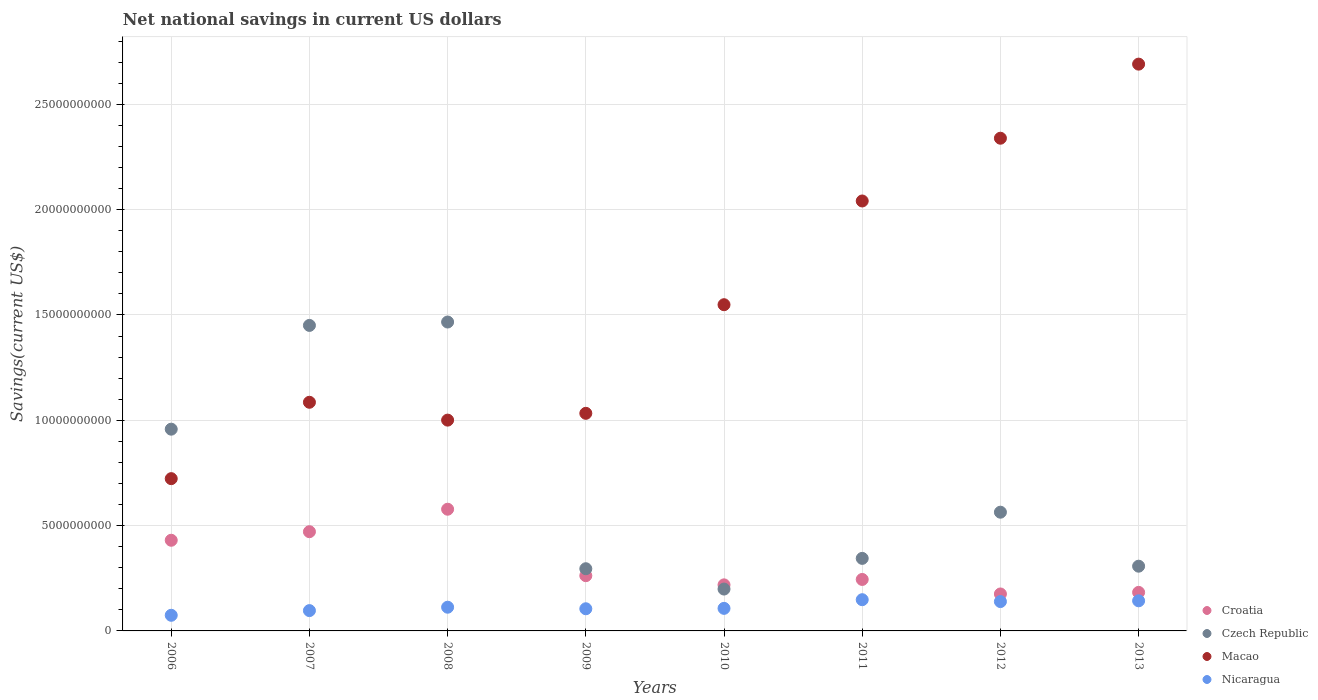What is the net national savings in Croatia in 2008?
Provide a short and direct response. 5.78e+09. Across all years, what is the maximum net national savings in Nicaragua?
Provide a short and direct response. 1.48e+09. Across all years, what is the minimum net national savings in Croatia?
Provide a succinct answer. 1.75e+09. What is the total net national savings in Croatia in the graph?
Keep it short and to the point. 2.56e+1. What is the difference between the net national savings in Macao in 2011 and that in 2013?
Ensure brevity in your answer.  -6.50e+09. What is the difference between the net national savings in Czech Republic in 2009 and the net national savings in Croatia in 2007?
Provide a succinct answer. -1.76e+09. What is the average net national savings in Macao per year?
Keep it short and to the point. 1.56e+1. In the year 2012, what is the difference between the net national savings in Nicaragua and net national savings in Croatia?
Your response must be concise. -3.61e+08. What is the ratio of the net national savings in Czech Republic in 2010 to that in 2013?
Offer a terse response. 0.65. What is the difference between the highest and the second highest net national savings in Nicaragua?
Your answer should be compact. 5.26e+07. What is the difference between the highest and the lowest net national savings in Nicaragua?
Offer a very short reply. 7.40e+08. In how many years, is the net national savings in Nicaragua greater than the average net national savings in Nicaragua taken over all years?
Give a very brief answer. 3. Is the sum of the net national savings in Macao in 2007 and 2011 greater than the maximum net national savings in Czech Republic across all years?
Ensure brevity in your answer.  Yes. Is it the case that in every year, the sum of the net national savings in Macao and net national savings in Croatia  is greater than the sum of net national savings in Nicaragua and net national savings in Czech Republic?
Keep it short and to the point. Yes. Does the net national savings in Macao monotonically increase over the years?
Your answer should be very brief. No. Is the net national savings in Czech Republic strictly less than the net national savings in Croatia over the years?
Provide a succinct answer. No. How many dotlines are there?
Keep it short and to the point. 4. How many years are there in the graph?
Your response must be concise. 8. Where does the legend appear in the graph?
Your response must be concise. Bottom right. How many legend labels are there?
Provide a succinct answer. 4. How are the legend labels stacked?
Give a very brief answer. Vertical. What is the title of the graph?
Keep it short and to the point. Net national savings in current US dollars. What is the label or title of the X-axis?
Make the answer very short. Years. What is the label or title of the Y-axis?
Keep it short and to the point. Savings(current US$). What is the Savings(current US$) of Croatia in 2006?
Your answer should be compact. 4.30e+09. What is the Savings(current US$) in Czech Republic in 2006?
Your response must be concise. 9.58e+09. What is the Savings(current US$) of Macao in 2006?
Provide a succinct answer. 7.23e+09. What is the Savings(current US$) in Nicaragua in 2006?
Ensure brevity in your answer.  7.42e+08. What is the Savings(current US$) in Croatia in 2007?
Give a very brief answer. 4.71e+09. What is the Savings(current US$) of Czech Republic in 2007?
Offer a terse response. 1.45e+1. What is the Savings(current US$) of Macao in 2007?
Keep it short and to the point. 1.09e+1. What is the Savings(current US$) in Nicaragua in 2007?
Your response must be concise. 9.64e+08. What is the Savings(current US$) of Croatia in 2008?
Your response must be concise. 5.78e+09. What is the Savings(current US$) of Czech Republic in 2008?
Make the answer very short. 1.47e+1. What is the Savings(current US$) in Macao in 2008?
Your response must be concise. 1.00e+1. What is the Savings(current US$) in Nicaragua in 2008?
Your answer should be very brief. 1.13e+09. What is the Savings(current US$) of Croatia in 2009?
Ensure brevity in your answer.  2.62e+09. What is the Savings(current US$) of Czech Republic in 2009?
Offer a terse response. 2.95e+09. What is the Savings(current US$) in Macao in 2009?
Your response must be concise. 1.03e+1. What is the Savings(current US$) in Nicaragua in 2009?
Your answer should be very brief. 1.05e+09. What is the Savings(current US$) in Croatia in 2010?
Provide a succinct answer. 2.19e+09. What is the Savings(current US$) in Czech Republic in 2010?
Your answer should be very brief. 1.99e+09. What is the Savings(current US$) of Macao in 2010?
Ensure brevity in your answer.  1.55e+1. What is the Savings(current US$) of Nicaragua in 2010?
Provide a succinct answer. 1.07e+09. What is the Savings(current US$) in Croatia in 2011?
Provide a short and direct response. 2.44e+09. What is the Savings(current US$) of Czech Republic in 2011?
Your response must be concise. 3.44e+09. What is the Savings(current US$) of Macao in 2011?
Provide a succinct answer. 2.04e+1. What is the Savings(current US$) in Nicaragua in 2011?
Give a very brief answer. 1.48e+09. What is the Savings(current US$) in Croatia in 2012?
Give a very brief answer. 1.75e+09. What is the Savings(current US$) in Czech Republic in 2012?
Offer a very short reply. 5.64e+09. What is the Savings(current US$) in Macao in 2012?
Provide a succinct answer. 2.34e+1. What is the Savings(current US$) in Nicaragua in 2012?
Your response must be concise. 1.39e+09. What is the Savings(current US$) in Croatia in 2013?
Provide a succinct answer. 1.83e+09. What is the Savings(current US$) in Czech Republic in 2013?
Your response must be concise. 3.07e+09. What is the Savings(current US$) in Macao in 2013?
Keep it short and to the point. 2.69e+1. What is the Savings(current US$) of Nicaragua in 2013?
Your answer should be very brief. 1.43e+09. Across all years, what is the maximum Savings(current US$) of Croatia?
Ensure brevity in your answer.  5.78e+09. Across all years, what is the maximum Savings(current US$) of Czech Republic?
Ensure brevity in your answer.  1.47e+1. Across all years, what is the maximum Savings(current US$) in Macao?
Ensure brevity in your answer.  2.69e+1. Across all years, what is the maximum Savings(current US$) in Nicaragua?
Ensure brevity in your answer.  1.48e+09. Across all years, what is the minimum Savings(current US$) in Croatia?
Your response must be concise. 1.75e+09. Across all years, what is the minimum Savings(current US$) in Czech Republic?
Make the answer very short. 1.99e+09. Across all years, what is the minimum Savings(current US$) of Macao?
Give a very brief answer. 7.23e+09. Across all years, what is the minimum Savings(current US$) in Nicaragua?
Your answer should be very brief. 7.42e+08. What is the total Savings(current US$) in Croatia in the graph?
Ensure brevity in your answer.  2.56e+1. What is the total Savings(current US$) of Czech Republic in the graph?
Your response must be concise. 5.58e+1. What is the total Savings(current US$) in Macao in the graph?
Your response must be concise. 1.25e+11. What is the total Savings(current US$) in Nicaragua in the graph?
Provide a short and direct response. 9.26e+09. What is the difference between the Savings(current US$) in Croatia in 2006 and that in 2007?
Ensure brevity in your answer.  -4.07e+08. What is the difference between the Savings(current US$) of Czech Republic in 2006 and that in 2007?
Your answer should be very brief. -4.93e+09. What is the difference between the Savings(current US$) of Macao in 2006 and that in 2007?
Give a very brief answer. -3.63e+09. What is the difference between the Savings(current US$) in Nicaragua in 2006 and that in 2007?
Provide a succinct answer. -2.22e+08. What is the difference between the Savings(current US$) in Croatia in 2006 and that in 2008?
Give a very brief answer. -1.47e+09. What is the difference between the Savings(current US$) in Czech Republic in 2006 and that in 2008?
Your answer should be very brief. -5.09e+09. What is the difference between the Savings(current US$) in Macao in 2006 and that in 2008?
Offer a terse response. -2.78e+09. What is the difference between the Savings(current US$) in Nicaragua in 2006 and that in 2008?
Your answer should be very brief. -3.83e+08. What is the difference between the Savings(current US$) in Croatia in 2006 and that in 2009?
Provide a succinct answer. 1.68e+09. What is the difference between the Savings(current US$) of Czech Republic in 2006 and that in 2009?
Offer a very short reply. 6.63e+09. What is the difference between the Savings(current US$) in Macao in 2006 and that in 2009?
Your response must be concise. -3.10e+09. What is the difference between the Savings(current US$) of Nicaragua in 2006 and that in 2009?
Ensure brevity in your answer.  -3.10e+08. What is the difference between the Savings(current US$) of Croatia in 2006 and that in 2010?
Your answer should be very brief. 2.12e+09. What is the difference between the Savings(current US$) of Czech Republic in 2006 and that in 2010?
Ensure brevity in your answer.  7.59e+09. What is the difference between the Savings(current US$) in Macao in 2006 and that in 2010?
Keep it short and to the point. -8.26e+09. What is the difference between the Savings(current US$) in Nicaragua in 2006 and that in 2010?
Your answer should be very brief. -3.29e+08. What is the difference between the Savings(current US$) in Croatia in 2006 and that in 2011?
Your response must be concise. 1.86e+09. What is the difference between the Savings(current US$) of Czech Republic in 2006 and that in 2011?
Give a very brief answer. 6.13e+09. What is the difference between the Savings(current US$) in Macao in 2006 and that in 2011?
Provide a succinct answer. -1.32e+1. What is the difference between the Savings(current US$) in Nicaragua in 2006 and that in 2011?
Keep it short and to the point. -7.40e+08. What is the difference between the Savings(current US$) in Croatia in 2006 and that in 2012?
Provide a short and direct response. 2.55e+09. What is the difference between the Savings(current US$) in Czech Republic in 2006 and that in 2012?
Make the answer very short. 3.94e+09. What is the difference between the Savings(current US$) in Macao in 2006 and that in 2012?
Your answer should be very brief. -1.62e+1. What is the difference between the Savings(current US$) in Nicaragua in 2006 and that in 2012?
Keep it short and to the point. -6.51e+08. What is the difference between the Savings(current US$) of Croatia in 2006 and that in 2013?
Ensure brevity in your answer.  2.47e+09. What is the difference between the Savings(current US$) in Czech Republic in 2006 and that in 2013?
Your answer should be compact. 6.50e+09. What is the difference between the Savings(current US$) of Macao in 2006 and that in 2013?
Offer a terse response. -1.97e+1. What is the difference between the Savings(current US$) in Nicaragua in 2006 and that in 2013?
Provide a short and direct response. -6.87e+08. What is the difference between the Savings(current US$) in Croatia in 2007 and that in 2008?
Your answer should be very brief. -1.07e+09. What is the difference between the Savings(current US$) in Czech Republic in 2007 and that in 2008?
Your answer should be compact. -1.61e+08. What is the difference between the Savings(current US$) of Macao in 2007 and that in 2008?
Ensure brevity in your answer.  8.47e+08. What is the difference between the Savings(current US$) in Nicaragua in 2007 and that in 2008?
Keep it short and to the point. -1.61e+08. What is the difference between the Savings(current US$) of Croatia in 2007 and that in 2009?
Make the answer very short. 2.09e+09. What is the difference between the Savings(current US$) of Czech Republic in 2007 and that in 2009?
Make the answer very short. 1.16e+1. What is the difference between the Savings(current US$) of Macao in 2007 and that in 2009?
Provide a short and direct response. 5.25e+08. What is the difference between the Savings(current US$) in Nicaragua in 2007 and that in 2009?
Provide a succinct answer. -8.77e+07. What is the difference between the Savings(current US$) in Croatia in 2007 and that in 2010?
Provide a short and direct response. 2.52e+09. What is the difference between the Savings(current US$) of Czech Republic in 2007 and that in 2010?
Your response must be concise. 1.25e+1. What is the difference between the Savings(current US$) of Macao in 2007 and that in 2010?
Offer a very short reply. -4.63e+09. What is the difference between the Savings(current US$) in Nicaragua in 2007 and that in 2010?
Your answer should be compact. -1.07e+08. What is the difference between the Savings(current US$) of Croatia in 2007 and that in 2011?
Make the answer very short. 2.27e+09. What is the difference between the Savings(current US$) of Czech Republic in 2007 and that in 2011?
Make the answer very short. 1.11e+1. What is the difference between the Savings(current US$) in Macao in 2007 and that in 2011?
Your answer should be very brief. -9.56e+09. What is the difference between the Savings(current US$) of Nicaragua in 2007 and that in 2011?
Your answer should be compact. -5.18e+08. What is the difference between the Savings(current US$) in Croatia in 2007 and that in 2012?
Offer a terse response. 2.96e+09. What is the difference between the Savings(current US$) in Czech Republic in 2007 and that in 2012?
Give a very brief answer. 8.87e+09. What is the difference between the Savings(current US$) of Macao in 2007 and that in 2012?
Your response must be concise. -1.25e+1. What is the difference between the Savings(current US$) in Nicaragua in 2007 and that in 2012?
Offer a very short reply. -4.29e+08. What is the difference between the Savings(current US$) of Croatia in 2007 and that in 2013?
Ensure brevity in your answer.  2.88e+09. What is the difference between the Savings(current US$) of Czech Republic in 2007 and that in 2013?
Your answer should be very brief. 1.14e+1. What is the difference between the Savings(current US$) in Macao in 2007 and that in 2013?
Ensure brevity in your answer.  -1.61e+1. What is the difference between the Savings(current US$) of Nicaragua in 2007 and that in 2013?
Your answer should be very brief. -4.65e+08. What is the difference between the Savings(current US$) of Croatia in 2008 and that in 2009?
Ensure brevity in your answer.  3.16e+09. What is the difference between the Savings(current US$) in Czech Republic in 2008 and that in 2009?
Your response must be concise. 1.17e+1. What is the difference between the Savings(current US$) of Macao in 2008 and that in 2009?
Make the answer very short. -3.23e+08. What is the difference between the Savings(current US$) of Nicaragua in 2008 and that in 2009?
Ensure brevity in your answer.  7.33e+07. What is the difference between the Savings(current US$) of Croatia in 2008 and that in 2010?
Make the answer very short. 3.59e+09. What is the difference between the Savings(current US$) in Czech Republic in 2008 and that in 2010?
Offer a very short reply. 1.27e+1. What is the difference between the Savings(current US$) of Macao in 2008 and that in 2010?
Your response must be concise. -5.48e+09. What is the difference between the Savings(current US$) of Nicaragua in 2008 and that in 2010?
Keep it short and to the point. 5.43e+07. What is the difference between the Savings(current US$) in Croatia in 2008 and that in 2011?
Give a very brief answer. 3.33e+09. What is the difference between the Savings(current US$) of Czech Republic in 2008 and that in 2011?
Your answer should be compact. 1.12e+1. What is the difference between the Savings(current US$) in Macao in 2008 and that in 2011?
Provide a short and direct response. -1.04e+1. What is the difference between the Savings(current US$) in Nicaragua in 2008 and that in 2011?
Your answer should be very brief. -3.57e+08. What is the difference between the Savings(current US$) of Croatia in 2008 and that in 2012?
Your answer should be very brief. 4.02e+09. What is the difference between the Savings(current US$) of Czech Republic in 2008 and that in 2012?
Your answer should be compact. 9.03e+09. What is the difference between the Savings(current US$) of Macao in 2008 and that in 2012?
Provide a short and direct response. -1.34e+1. What is the difference between the Savings(current US$) of Nicaragua in 2008 and that in 2012?
Provide a short and direct response. -2.68e+08. What is the difference between the Savings(current US$) of Croatia in 2008 and that in 2013?
Your answer should be compact. 3.95e+09. What is the difference between the Savings(current US$) in Czech Republic in 2008 and that in 2013?
Provide a short and direct response. 1.16e+1. What is the difference between the Savings(current US$) in Macao in 2008 and that in 2013?
Provide a short and direct response. -1.69e+1. What is the difference between the Savings(current US$) of Nicaragua in 2008 and that in 2013?
Provide a short and direct response. -3.04e+08. What is the difference between the Savings(current US$) in Croatia in 2009 and that in 2010?
Your response must be concise. 4.35e+08. What is the difference between the Savings(current US$) of Czech Republic in 2009 and that in 2010?
Your answer should be very brief. 9.65e+08. What is the difference between the Savings(current US$) of Macao in 2009 and that in 2010?
Keep it short and to the point. -5.16e+09. What is the difference between the Savings(current US$) in Nicaragua in 2009 and that in 2010?
Ensure brevity in your answer.  -1.91e+07. What is the difference between the Savings(current US$) of Croatia in 2009 and that in 2011?
Your response must be concise. 1.79e+08. What is the difference between the Savings(current US$) in Czech Republic in 2009 and that in 2011?
Keep it short and to the point. -4.91e+08. What is the difference between the Savings(current US$) in Macao in 2009 and that in 2011?
Ensure brevity in your answer.  -1.01e+1. What is the difference between the Savings(current US$) in Nicaragua in 2009 and that in 2011?
Give a very brief answer. -4.30e+08. What is the difference between the Savings(current US$) of Croatia in 2009 and that in 2012?
Offer a very short reply. 8.68e+08. What is the difference between the Savings(current US$) in Czech Republic in 2009 and that in 2012?
Your response must be concise. -2.68e+09. What is the difference between the Savings(current US$) of Macao in 2009 and that in 2012?
Offer a very short reply. -1.31e+1. What is the difference between the Savings(current US$) of Nicaragua in 2009 and that in 2012?
Provide a short and direct response. -3.41e+08. What is the difference between the Savings(current US$) in Croatia in 2009 and that in 2013?
Offer a terse response. 7.92e+08. What is the difference between the Savings(current US$) of Czech Republic in 2009 and that in 2013?
Provide a succinct answer. -1.21e+08. What is the difference between the Savings(current US$) in Macao in 2009 and that in 2013?
Your answer should be compact. -1.66e+1. What is the difference between the Savings(current US$) of Nicaragua in 2009 and that in 2013?
Provide a succinct answer. -3.78e+08. What is the difference between the Savings(current US$) in Croatia in 2010 and that in 2011?
Provide a succinct answer. -2.57e+08. What is the difference between the Savings(current US$) in Czech Republic in 2010 and that in 2011?
Your answer should be very brief. -1.46e+09. What is the difference between the Savings(current US$) in Macao in 2010 and that in 2011?
Offer a terse response. -4.92e+09. What is the difference between the Savings(current US$) in Nicaragua in 2010 and that in 2011?
Give a very brief answer. -4.11e+08. What is the difference between the Savings(current US$) of Croatia in 2010 and that in 2012?
Offer a very short reply. 4.32e+08. What is the difference between the Savings(current US$) of Czech Republic in 2010 and that in 2012?
Your response must be concise. -3.65e+09. What is the difference between the Savings(current US$) in Macao in 2010 and that in 2012?
Make the answer very short. -7.90e+09. What is the difference between the Savings(current US$) in Nicaragua in 2010 and that in 2012?
Offer a very short reply. -3.22e+08. What is the difference between the Savings(current US$) in Croatia in 2010 and that in 2013?
Give a very brief answer. 3.57e+08. What is the difference between the Savings(current US$) in Czech Republic in 2010 and that in 2013?
Your answer should be very brief. -1.09e+09. What is the difference between the Savings(current US$) of Macao in 2010 and that in 2013?
Offer a very short reply. -1.14e+1. What is the difference between the Savings(current US$) of Nicaragua in 2010 and that in 2013?
Give a very brief answer. -3.58e+08. What is the difference between the Savings(current US$) in Croatia in 2011 and that in 2012?
Give a very brief answer. 6.89e+08. What is the difference between the Savings(current US$) in Czech Republic in 2011 and that in 2012?
Your answer should be very brief. -2.19e+09. What is the difference between the Savings(current US$) in Macao in 2011 and that in 2012?
Ensure brevity in your answer.  -2.98e+09. What is the difference between the Savings(current US$) of Nicaragua in 2011 and that in 2012?
Give a very brief answer. 8.87e+07. What is the difference between the Savings(current US$) in Croatia in 2011 and that in 2013?
Make the answer very short. 6.13e+08. What is the difference between the Savings(current US$) of Czech Republic in 2011 and that in 2013?
Your answer should be very brief. 3.71e+08. What is the difference between the Savings(current US$) in Macao in 2011 and that in 2013?
Your response must be concise. -6.50e+09. What is the difference between the Savings(current US$) in Nicaragua in 2011 and that in 2013?
Make the answer very short. 5.26e+07. What is the difference between the Savings(current US$) in Croatia in 2012 and that in 2013?
Provide a succinct answer. -7.56e+07. What is the difference between the Savings(current US$) of Czech Republic in 2012 and that in 2013?
Offer a very short reply. 2.56e+09. What is the difference between the Savings(current US$) in Macao in 2012 and that in 2013?
Your response must be concise. -3.52e+09. What is the difference between the Savings(current US$) of Nicaragua in 2012 and that in 2013?
Make the answer very short. -3.61e+07. What is the difference between the Savings(current US$) of Croatia in 2006 and the Savings(current US$) of Czech Republic in 2007?
Your answer should be compact. -1.02e+1. What is the difference between the Savings(current US$) of Croatia in 2006 and the Savings(current US$) of Macao in 2007?
Your answer should be very brief. -6.55e+09. What is the difference between the Savings(current US$) in Croatia in 2006 and the Savings(current US$) in Nicaragua in 2007?
Your answer should be compact. 3.34e+09. What is the difference between the Savings(current US$) of Czech Republic in 2006 and the Savings(current US$) of Macao in 2007?
Your answer should be very brief. -1.28e+09. What is the difference between the Savings(current US$) of Czech Republic in 2006 and the Savings(current US$) of Nicaragua in 2007?
Your answer should be compact. 8.61e+09. What is the difference between the Savings(current US$) of Macao in 2006 and the Savings(current US$) of Nicaragua in 2007?
Your answer should be compact. 6.26e+09. What is the difference between the Savings(current US$) of Croatia in 2006 and the Savings(current US$) of Czech Republic in 2008?
Give a very brief answer. -1.04e+1. What is the difference between the Savings(current US$) in Croatia in 2006 and the Savings(current US$) in Macao in 2008?
Provide a succinct answer. -5.70e+09. What is the difference between the Savings(current US$) of Croatia in 2006 and the Savings(current US$) of Nicaragua in 2008?
Provide a short and direct response. 3.18e+09. What is the difference between the Savings(current US$) in Czech Republic in 2006 and the Savings(current US$) in Macao in 2008?
Provide a short and direct response. -4.30e+08. What is the difference between the Savings(current US$) in Czech Republic in 2006 and the Savings(current US$) in Nicaragua in 2008?
Keep it short and to the point. 8.45e+09. What is the difference between the Savings(current US$) of Macao in 2006 and the Savings(current US$) of Nicaragua in 2008?
Ensure brevity in your answer.  6.10e+09. What is the difference between the Savings(current US$) in Croatia in 2006 and the Savings(current US$) in Czech Republic in 2009?
Offer a very short reply. 1.35e+09. What is the difference between the Savings(current US$) of Croatia in 2006 and the Savings(current US$) of Macao in 2009?
Offer a terse response. -6.03e+09. What is the difference between the Savings(current US$) in Croatia in 2006 and the Savings(current US$) in Nicaragua in 2009?
Provide a succinct answer. 3.25e+09. What is the difference between the Savings(current US$) in Czech Republic in 2006 and the Savings(current US$) in Macao in 2009?
Make the answer very short. -7.53e+08. What is the difference between the Savings(current US$) of Czech Republic in 2006 and the Savings(current US$) of Nicaragua in 2009?
Provide a short and direct response. 8.53e+09. What is the difference between the Savings(current US$) in Macao in 2006 and the Savings(current US$) in Nicaragua in 2009?
Make the answer very short. 6.18e+09. What is the difference between the Savings(current US$) of Croatia in 2006 and the Savings(current US$) of Czech Republic in 2010?
Offer a terse response. 2.32e+09. What is the difference between the Savings(current US$) in Croatia in 2006 and the Savings(current US$) in Macao in 2010?
Your answer should be compact. -1.12e+1. What is the difference between the Savings(current US$) in Croatia in 2006 and the Savings(current US$) in Nicaragua in 2010?
Make the answer very short. 3.23e+09. What is the difference between the Savings(current US$) of Czech Republic in 2006 and the Savings(current US$) of Macao in 2010?
Provide a succinct answer. -5.91e+09. What is the difference between the Savings(current US$) in Czech Republic in 2006 and the Savings(current US$) in Nicaragua in 2010?
Offer a very short reply. 8.51e+09. What is the difference between the Savings(current US$) of Macao in 2006 and the Savings(current US$) of Nicaragua in 2010?
Offer a very short reply. 6.16e+09. What is the difference between the Savings(current US$) of Croatia in 2006 and the Savings(current US$) of Czech Republic in 2011?
Provide a succinct answer. 8.60e+08. What is the difference between the Savings(current US$) of Croatia in 2006 and the Savings(current US$) of Macao in 2011?
Give a very brief answer. -1.61e+1. What is the difference between the Savings(current US$) in Croatia in 2006 and the Savings(current US$) in Nicaragua in 2011?
Provide a succinct answer. 2.82e+09. What is the difference between the Savings(current US$) in Czech Republic in 2006 and the Savings(current US$) in Macao in 2011?
Your response must be concise. -1.08e+1. What is the difference between the Savings(current US$) of Czech Republic in 2006 and the Savings(current US$) of Nicaragua in 2011?
Your answer should be compact. 8.10e+09. What is the difference between the Savings(current US$) in Macao in 2006 and the Savings(current US$) in Nicaragua in 2011?
Give a very brief answer. 5.75e+09. What is the difference between the Savings(current US$) of Croatia in 2006 and the Savings(current US$) of Czech Republic in 2012?
Offer a very short reply. -1.33e+09. What is the difference between the Savings(current US$) of Croatia in 2006 and the Savings(current US$) of Macao in 2012?
Provide a succinct answer. -1.91e+1. What is the difference between the Savings(current US$) in Croatia in 2006 and the Savings(current US$) in Nicaragua in 2012?
Provide a succinct answer. 2.91e+09. What is the difference between the Savings(current US$) of Czech Republic in 2006 and the Savings(current US$) of Macao in 2012?
Give a very brief answer. -1.38e+1. What is the difference between the Savings(current US$) of Czech Republic in 2006 and the Savings(current US$) of Nicaragua in 2012?
Offer a very short reply. 8.18e+09. What is the difference between the Savings(current US$) of Macao in 2006 and the Savings(current US$) of Nicaragua in 2012?
Your response must be concise. 5.84e+09. What is the difference between the Savings(current US$) in Croatia in 2006 and the Savings(current US$) in Czech Republic in 2013?
Make the answer very short. 1.23e+09. What is the difference between the Savings(current US$) of Croatia in 2006 and the Savings(current US$) of Macao in 2013?
Provide a succinct answer. -2.26e+1. What is the difference between the Savings(current US$) in Croatia in 2006 and the Savings(current US$) in Nicaragua in 2013?
Give a very brief answer. 2.87e+09. What is the difference between the Savings(current US$) of Czech Republic in 2006 and the Savings(current US$) of Macao in 2013?
Your response must be concise. -1.73e+1. What is the difference between the Savings(current US$) of Czech Republic in 2006 and the Savings(current US$) of Nicaragua in 2013?
Offer a very short reply. 8.15e+09. What is the difference between the Savings(current US$) of Macao in 2006 and the Savings(current US$) of Nicaragua in 2013?
Ensure brevity in your answer.  5.80e+09. What is the difference between the Savings(current US$) of Croatia in 2007 and the Savings(current US$) of Czech Republic in 2008?
Offer a terse response. -9.95e+09. What is the difference between the Savings(current US$) in Croatia in 2007 and the Savings(current US$) in Macao in 2008?
Offer a very short reply. -5.30e+09. What is the difference between the Savings(current US$) in Croatia in 2007 and the Savings(current US$) in Nicaragua in 2008?
Provide a succinct answer. 3.59e+09. What is the difference between the Savings(current US$) in Czech Republic in 2007 and the Savings(current US$) in Macao in 2008?
Ensure brevity in your answer.  4.50e+09. What is the difference between the Savings(current US$) in Czech Republic in 2007 and the Savings(current US$) in Nicaragua in 2008?
Make the answer very short. 1.34e+1. What is the difference between the Savings(current US$) in Macao in 2007 and the Savings(current US$) in Nicaragua in 2008?
Provide a succinct answer. 9.73e+09. What is the difference between the Savings(current US$) of Croatia in 2007 and the Savings(current US$) of Czech Republic in 2009?
Make the answer very short. 1.76e+09. What is the difference between the Savings(current US$) in Croatia in 2007 and the Savings(current US$) in Macao in 2009?
Provide a succinct answer. -5.62e+09. What is the difference between the Savings(current US$) in Croatia in 2007 and the Savings(current US$) in Nicaragua in 2009?
Your answer should be compact. 3.66e+09. What is the difference between the Savings(current US$) of Czech Republic in 2007 and the Savings(current US$) of Macao in 2009?
Give a very brief answer. 4.17e+09. What is the difference between the Savings(current US$) in Czech Republic in 2007 and the Savings(current US$) in Nicaragua in 2009?
Give a very brief answer. 1.35e+1. What is the difference between the Savings(current US$) in Macao in 2007 and the Savings(current US$) in Nicaragua in 2009?
Provide a short and direct response. 9.80e+09. What is the difference between the Savings(current US$) of Croatia in 2007 and the Savings(current US$) of Czech Republic in 2010?
Your answer should be very brief. 2.72e+09. What is the difference between the Savings(current US$) of Croatia in 2007 and the Savings(current US$) of Macao in 2010?
Your response must be concise. -1.08e+1. What is the difference between the Savings(current US$) in Croatia in 2007 and the Savings(current US$) in Nicaragua in 2010?
Give a very brief answer. 3.64e+09. What is the difference between the Savings(current US$) in Czech Republic in 2007 and the Savings(current US$) in Macao in 2010?
Give a very brief answer. -9.83e+08. What is the difference between the Savings(current US$) in Czech Republic in 2007 and the Savings(current US$) in Nicaragua in 2010?
Offer a very short reply. 1.34e+1. What is the difference between the Savings(current US$) of Macao in 2007 and the Savings(current US$) of Nicaragua in 2010?
Your response must be concise. 9.78e+09. What is the difference between the Savings(current US$) of Croatia in 2007 and the Savings(current US$) of Czech Republic in 2011?
Ensure brevity in your answer.  1.27e+09. What is the difference between the Savings(current US$) of Croatia in 2007 and the Savings(current US$) of Macao in 2011?
Provide a succinct answer. -1.57e+1. What is the difference between the Savings(current US$) of Croatia in 2007 and the Savings(current US$) of Nicaragua in 2011?
Your response must be concise. 3.23e+09. What is the difference between the Savings(current US$) of Czech Republic in 2007 and the Savings(current US$) of Macao in 2011?
Your response must be concise. -5.91e+09. What is the difference between the Savings(current US$) of Czech Republic in 2007 and the Savings(current US$) of Nicaragua in 2011?
Offer a very short reply. 1.30e+1. What is the difference between the Savings(current US$) in Macao in 2007 and the Savings(current US$) in Nicaragua in 2011?
Ensure brevity in your answer.  9.37e+09. What is the difference between the Savings(current US$) in Croatia in 2007 and the Savings(current US$) in Czech Republic in 2012?
Provide a short and direct response. -9.26e+08. What is the difference between the Savings(current US$) of Croatia in 2007 and the Savings(current US$) of Macao in 2012?
Make the answer very short. -1.87e+1. What is the difference between the Savings(current US$) of Croatia in 2007 and the Savings(current US$) of Nicaragua in 2012?
Make the answer very short. 3.32e+09. What is the difference between the Savings(current US$) of Czech Republic in 2007 and the Savings(current US$) of Macao in 2012?
Give a very brief answer. -8.89e+09. What is the difference between the Savings(current US$) in Czech Republic in 2007 and the Savings(current US$) in Nicaragua in 2012?
Provide a succinct answer. 1.31e+1. What is the difference between the Savings(current US$) of Macao in 2007 and the Savings(current US$) of Nicaragua in 2012?
Ensure brevity in your answer.  9.46e+09. What is the difference between the Savings(current US$) in Croatia in 2007 and the Savings(current US$) in Czech Republic in 2013?
Ensure brevity in your answer.  1.64e+09. What is the difference between the Savings(current US$) of Croatia in 2007 and the Savings(current US$) of Macao in 2013?
Your response must be concise. -2.22e+1. What is the difference between the Savings(current US$) in Croatia in 2007 and the Savings(current US$) in Nicaragua in 2013?
Your answer should be compact. 3.28e+09. What is the difference between the Savings(current US$) in Czech Republic in 2007 and the Savings(current US$) in Macao in 2013?
Offer a very short reply. -1.24e+1. What is the difference between the Savings(current US$) of Czech Republic in 2007 and the Savings(current US$) of Nicaragua in 2013?
Give a very brief answer. 1.31e+1. What is the difference between the Savings(current US$) of Macao in 2007 and the Savings(current US$) of Nicaragua in 2013?
Provide a short and direct response. 9.43e+09. What is the difference between the Savings(current US$) in Croatia in 2008 and the Savings(current US$) in Czech Republic in 2009?
Give a very brief answer. 2.83e+09. What is the difference between the Savings(current US$) of Croatia in 2008 and the Savings(current US$) of Macao in 2009?
Keep it short and to the point. -4.55e+09. What is the difference between the Savings(current US$) in Croatia in 2008 and the Savings(current US$) in Nicaragua in 2009?
Keep it short and to the point. 4.73e+09. What is the difference between the Savings(current US$) in Czech Republic in 2008 and the Savings(current US$) in Macao in 2009?
Provide a short and direct response. 4.33e+09. What is the difference between the Savings(current US$) of Czech Republic in 2008 and the Savings(current US$) of Nicaragua in 2009?
Keep it short and to the point. 1.36e+1. What is the difference between the Savings(current US$) in Macao in 2008 and the Savings(current US$) in Nicaragua in 2009?
Your response must be concise. 8.96e+09. What is the difference between the Savings(current US$) in Croatia in 2008 and the Savings(current US$) in Czech Republic in 2010?
Provide a succinct answer. 3.79e+09. What is the difference between the Savings(current US$) of Croatia in 2008 and the Savings(current US$) of Macao in 2010?
Give a very brief answer. -9.71e+09. What is the difference between the Savings(current US$) in Croatia in 2008 and the Savings(current US$) in Nicaragua in 2010?
Ensure brevity in your answer.  4.71e+09. What is the difference between the Savings(current US$) of Czech Republic in 2008 and the Savings(current US$) of Macao in 2010?
Offer a terse response. -8.22e+08. What is the difference between the Savings(current US$) in Czech Republic in 2008 and the Savings(current US$) in Nicaragua in 2010?
Keep it short and to the point. 1.36e+1. What is the difference between the Savings(current US$) of Macao in 2008 and the Savings(current US$) of Nicaragua in 2010?
Give a very brief answer. 8.94e+09. What is the difference between the Savings(current US$) in Croatia in 2008 and the Savings(current US$) in Czech Republic in 2011?
Your response must be concise. 2.33e+09. What is the difference between the Savings(current US$) in Croatia in 2008 and the Savings(current US$) in Macao in 2011?
Your answer should be compact. -1.46e+1. What is the difference between the Savings(current US$) of Croatia in 2008 and the Savings(current US$) of Nicaragua in 2011?
Provide a short and direct response. 4.30e+09. What is the difference between the Savings(current US$) in Czech Republic in 2008 and the Savings(current US$) in Macao in 2011?
Your answer should be very brief. -5.75e+09. What is the difference between the Savings(current US$) of Czech Republic in 2008 and the Savings(current US$) of Nicaragua in 2011?
Keep it short and to the point. 1.32e+1. What is the difference between the Savings(current US$) of Macao in 2008 and the Savings(current US$) of Nicaragua in 2011?
Provide a succinct answer. 8.53e+09. What is the difference between the Savings(current US$) of Croatia in 2008 and the Savings(current US$) of Czech Republic in 2012?
Make the answer very short. 1.41e+08. What is the difference between the Savings(current US$) in Croatia in 2008 and the Savings(current US$) in Macao in 2012?
Keep it short and to the point. -1.76e+1. What is the difference between the Savings(current US$) of Croatia in 2008 and the Savings(current US$) of Nicaragua in 2012?
Provide a succinct answer. 4.38e+09. What is the difference between the Savings(current US$) of Czech Republic in 2008 and the Savings(current US$) of Macao in 2012?
Offer a terse response. -8.73e+09. What is the difference between the Savings(current US$) in Czech Republic in 2008 and the Savings(current US$) in Nicaragua in 2012?
Ensure brevity in your answer.  1.33e+1. What is the difference between the Savings(current US$) in Macao in 2008 and the Savings(current US$) in Nicaragua in 2012?
Your answer should be compact. 8.61e+09. What is the difference between the Savings(current US$) of Croatia in 2008 and the Savings(current US$) of Czech Republic in 2013?
Give a very brief answer. 2.70e+09. What is the difference between the Savings(current US$) in Croatia in 2008 and the Savings(current US$) in Macao in 2013?
Provide a succinct answer. -2.11e+1. What is the difference between the Savings(current US$) of Croatia in 2008 and the Savings(current US$) of Nicaragua in 2013?
Make the answer very short. 4.35e+09. What is the difference between the Savings(current US$) in Czech Republic in 2008 and the Savings(current US$) in Macao in 2013?
Provide a short and direct response. -1.22e+1. What is the difference between the Savings(current US$) of Czech Republic in 2008 and the Savings(current US$) of Nicaragua in 2013?
Ensure brevity in your answer.  1.32e+1. What is the difference between the Savings(current US$) in Macao in 2008 and the Savings(current US$) in Nicaragua in 2013?
Your answer should be compact. 8.58e+09. What is the difference between the Savings(current US$) of Croatia in 2009 and the Savings(current US$) of Czech Republic in 2010?
Offer a very short reply. 6.35e+08. What is the difference between the Savings(current US$) of Croatia in 2009 and the Savings(current US$) of Macao in 2010?
Offer a very short reply. -1.29e+1. What is the difference between the Savings(current US$) of Croatia in 2009 and the Savings(current US$) of Nicaragua in 2010?
Offer a terse response. 1.55e+09. What is the difference between the Savings(current US$) in Czech Republic in 2009 and the Savings(current US$) in Macao in 2010?
Provide a short and direct response. -1.25e+1. What is the difference between the Savings(current US$) in Czech Republic in 2009 and the Savings(current US$) in Nicaragua in 2010?
Your answer should be very brief. 1.88e+09. What is the difference between the Savings(current US$) in Macao in 2009 and the Savings(current US$) in Nicaragua in 2010?
Your response must be concise. 9.26e+09. What is the difference between the Savings(current US$) in Croatia in 2009 and the Savings(current US$) in Czech Republic in 2011?
Your answer should be very brief. -8.21e+08. What is the difference between the Savings(current US$) in Croatia in 2009 and the Savings(current US$) in Macao in 2011?
Your answer should be very brief. -1.78e+1. What is the difference between the Savings(current US$) in Croatia in 2009 and the Savings(current US$) in Nicaragua in 2011?
Give a very brief answer. 1.14e+09. What is the difference between the Savings(current US$) in Czech Republic in 2009 and the Savings(current US$) in Macao in 2011?
Your response must be concise. -1.75e+1. What is the difference between the Savings(current US$) of Czech Republic in 2009 and the Savings(current US$) of Nicaragua in 2011?
Keep it short and to the point. 1.47e+09. What is the difference between the Savings(current US$) in Macao in 2009 and the Savings(current US$) in Nicaragua in 2011?
Your answer should be compact. 8.85e+09. What is the difference between the Savings(current US$) of Croatia in 2009 and the Savings(current US$) of Czech Republic in 2012?
Your answer should be compact. -3.01e+09. What is the difference between the Savings(current US$) of Croatia in 2009 and the Savings(current US$) of Macao in 2012?
Ensure brevity in your answer.  -2.08e+1. What is the difference between the Savings(current US$) of Croatia in 2009 and the Savings(current US$) of Nicaragua in 2012?
Offer a very short reply. 1.23e+09. What is the difference between the Savings(current US$) of Czech Republic in 2009 and the Savings(current US$) of Macao in 2012?
Keep it short and to the point. -2.04e+1. What is the difference between the Savings(current US$) in Czech Republic in 2009 and the Savings(current US$) in Nicaragua in 2012?
Ensure brevity in your answer.  1.56e+09. What is the difference between the Savings(current US$) in Macao in 2009 and the Savings(current US$) in Nicaragua in 2012?
Keep it short and to the point. 8.94e+09. What is the difference between the Savings(current US$) of Croatia in 2009 and the Savings(current US$) of Czech Republic in 2013?
Make the answer very short. -4.51e+08. What is the difference between the Savings(current US$) of Croatia in 2009 and the Savings(current US$) of Macao in 2013?
Your response must be concise. -2.43e+1. What is the difference between the Savings(current US$) in Croatia in 2009 and the Savings(current US$) in Nicaragua in 2013?
Your answer should be very brief. 1.19e+09. What is the difference between the Savings(current US$) of Czech Republic in 2009 and the Savings(current US$) of Macao in 2013?
Provide a succinct answer. -2.40e+1. What is the difference between the Savings(current US$) of Czech Republic in 2009 and the Savings(current US$) of Nicaragua in 2013?
Give a very brief answer. 1.52e+09. What is the difference between the Savings(current US$) in Macao in 2009 and the Savings(current US$) in Nicaragua in 2013?
Make the answer very short. 8.90e+09. What is the difference between the Savings(current US$) of Croatia in 2010 and the Savings(current US$) of Czech Republic in 2011?
Offer a very short reply. -1.26e+09. What is the difference between the Savings(current US$) of Croatia in 2010 and the Savings(current US$) of Macao in 2011?
Your response must be concise. -1.82e+1. What is the difference between the Savings(current US$) in Croatia in 2010 and the Savings(current US$) in Nicaragua in 2011?
Your answer should be very brief. 7.05e+08. What is the difference between the Savings(current US$) in Czech Republic in 2010 and the Savings(current US$) in Macao in 2011?
Provide a succinct answer. -1.84e+1. What is the difference between the Savings(current US$) of Czech Republic in 2010 and the Savings(current US$) of Nicaragua in 2011?
Your answer should be very brief. 5.05e+08. What is the difference between the Savings(current US$) of Macao in 2010 and the Savings(current US$) of Nicaragua in 2011?
Provide a succinct answer. 1.40e+1. What is the difference between the Savings(current US$) of Croatia in 2010 and the Savings(current US$) of Czech Republic in 2012?
Keep it short and to the point. -3.45e+09. What is the difference between the Savings(current US$) in Croatia in 2010 and the Savings(current US$) in Macao in 2012?
Offer a terse response. -2.12e+1. What is the difference between the Savings(current US$) of Croatia in 2010 and the Savings(current US$) of Nicaragua in 2012?
Offer a terse response. 7.93e+08. What is the difference between the Savings(current US$) in Czech Republic in 2010 and the Savings(current US$) in Macao in 2012?
Make the answer very short. -2.14e+1. What is the difference between the Savings(current US$) of Czech Republic in 2010 and the Savings(current US$) of Nicaragua in 2012?
Keep it short and to the point. 5.94e+08. What is the difference between the Savings(current US$) of Macao in 2010 and the Savings(current US$) of Nicaragua in 2012?
Provide a short and direct response. 1.41e+1. What is the difference between the Savings(current US$) of Croatia in 2010 and the Savings(current US$) of Czech Republic in 2013?
Make the answer very short. -8.86e+08. What is the difference between the Savings(current US$) in Croatia in 2010 and the Savings(current US$) in Macao in 2013?
Give a very brief answer. -2.47e+1. What is the difference between the Savings(current US$) in Croatia in 2010 and the Savings(current US$) in Nicaragua in 2013?
Make the answer very short. 7.57e+08. What is the difference between the Savings(current US$) in Czech Republic in 2010 and the Savings(current US$) in Macao in 2013?
Your response must be concise. -2.49e+1. What is the difference between the Savings(current US$) in Czech Republic in 2010 and the Savings(current US$) in Nicaragua in 2013?
Your response must be concise. 5.58e+08. What is the difference between the Savings(current US$) of Macao in 2010 and the Savings(current US$) of Nicaragua in 2013?
Provide a succinct answer. 1.41e+1. What is the difference between the Savings(current US$) of Croatia in 2011 and the Savings(current US$) of Czech Republic in 2012?
Make the answer very short. -3.19e+09. What is the difference between the Savings(current US$) of Croatia in 2011 and the Savings(current US$) of Macao in 2012?
Keep it short and to the point. -2.09e+1. What is the difference between the Savings(current US$) of Croatia in 2011 and the Savings(current US$) of Nicaragua in 2012?
Provide a short and direct response. 1.05e+09. What is the difference between the Savings(current US$) in Czech Republic in 2011 and the Savings(current US$) in Macao in 2012?
Keep it short and to the point. -1.99e+1. What is the difference between the Savings(current US$) of Czech Republic in 2011 and the Savings(current US$) of Nicaragua in 2012?
Offer a terse response. 2.05e+09. What is the difference between the Savings(current US$) of Macao in 2011 and the Savings(current US$) of Nicaragua in 2012?
Make the answer very short. 1.90e+1. What is the difference between the Savings(current US$) of Croatia in 2011 and the Savings(current US$) of Czech Republic in 2013?
Provide a succinct answer. -6.30e+08. What is the difference between the Savings(current US$) of Croatia in 2011 and the Savings(current US$) of Macao in 2013?
Provide a succinct answer. -2.45e+1. What is the difference between the Savings(current US$) in Croatia in 2011 and the Savings(current US$) in Nicaragua in 2013?
Give a very brief answer. 1.01e+09. What is the difference between the Savings(current US$) in Czech Republic in 2011 and the Savings(current US$) in Macao in 2013?
Your answer should be compact. -2.35e+1. What is the difference between the Savings(current US$) of Czech Republic in 2011 and the Savings(current US$) of Nicaragua in 2013?
Your response must be concise. 2.01e+09. What is the difference between the Savings(current US$) in Macao in 2011 and the Savings(current US$) in Nicaragua in 2013?
Offer a terse response. 1.90e+1. What is the difference between the Savings(current US$) in Croatia in 2012 and the Savings(current US$) in Czech Republic in 2013?
Keep it short and to the point. -1.32e+09. What is the difference between the Savings(current US$) of Croatia in 2012 and the Savings(current US$) of Macao in 2013?
Ensure brevity in your answer.  -2.52e+1. What is the difference between the Savings(current US$) in Croatia in 2012 and the Savings(current US$) in Nicaragua in 2013?
Your answer should be compact. 3.25e+08. What is the difference between the Savings(current US$) of Czech Republic in 2012 and the Savings(current US$) of Macao in 2013?
Give a very brief answer. -2.13e+1. What is the difference between the Savings(current US$) of Czech Republic in 2012 and the Savings(current US$) of Nicaragua in 2013?
Keep it short and to the point. 4.21e+09. What is the difference between the Savings(current US$) of Macao in 2012 and the Savings(current US$) of Nicaragua in 2013?
Offer a very short reply. 2.20e+1. What is the average Savings(current US$) in Croatia per year?
Provide a succinct answer. 3.20e+09. What is the average Savings(current US$) in Czech Republic per year?
Ensure brevity in your answer.  6.98e+09. What is the average Savings(current US$) in Macao per year?
Your response must be concise. 1.56e+1. What is the average Savings(current US$) of Nicaragua per year?
Give a very brief answer. 1.16e+09. In the year 2006, what is the difference between the Savings(current US$) of Croatia and Savings(current US$) of Czech Republic?
Your answer should be compact. -5.27e+09. In the year 2006, what is the difference between the Savings(current US$) of Croatia and Savings(current US$) of Macao?
Keep it short and to the point. -2.93e+09. In the year 2006, what is the difference between the Savings(current US$) of Croatia and Savings(current US$) of Nicaragua?
Offer a very short reply. 3.56e+09. In the year 2006, what is the difference between the Savings(current US$) of Czech Republic and Savings(current US$) of Macao?
Give a very brief answer. 2.35e+09. In the year 2006, what is the difference between the Savings(current US$) of Czech Republic and Savings(current US$) of Nicaragua?
Your answer should be compact. 8.84e+09. In the year 2006, what is the difference between the Savings(current US$) in Macao and Savings(current US$) in Nicaragua?
Make the answer very short. 6.49e+09. In the year 2007, what is the difference between the Savings(current US$) of Croatia and Savings(current US$) of Czech Republic?
Provide a succinct answer. -9.79e+09. In the year 2007, what is the difference between the Savings(current US$) of Croatia and Savings(current US$) of Macao?
Give a very brief answer. -6.14e+09. In the year 2007, what is the difference between the Savings(current US$) of Croatia and Savings(current US$) of Nicaragua?
Your answer should be very brief. 3.75e+09. In the year 2007, what is the difference between the Savings(current US$) in Czech Republic and Savings(current US$) in Macao?
Offer a terse response. 3.65e+09. In the year 2007, what is the difference between the Savings(current US$) of Czech Republic and Savings(current US$) of Nicaragua?
Give a very brief answer. 1.35e+1. In the year 2007, what is the difference between the Savings(current US$) in Macao and Savings(current US$) in Nicaragua?
Your response must be concise. 9.89e+09. In the year 2008, what is the difference between the Savings(current US$) of Croatia and Savings(current US$) of Czech Republic?
Your answer should be compact. -8.89e+09. In the year 2008, what is the difference between the Savings(current US$) of Croatia and Savings(current US$) of Macao?
Offer a terse response. -4.23e+09. In the year 2008, what is the difference between the Savings(current US$) of Croatia and Savings(current US$) of Nicaragua?
Provide a short and direct response. 4.65e+09. In the year 2008, what is the difference between the Savings(current US$) of Czech Republic and Savings(current US$) of Macao?
Keep it short and to the point. 4.66e+09. In the year 2008, what is the difference between the Savings(current US$) in Czech Republic and Savings(current US$) in Nicaragua?
Keep it short and to the point. 1.35e+1. In the year 2008, what is the difference between the Savings(current US$) in Macao and Savings(current US$) in Nicaragua?
Provide a succinct answer. 8.88e+09. In the year 2009, what is the difference between the Savings(current US$) in Croatia and Savings(current US$) in Czech Republic?
Make the answer very short. -3.30e+08. In the year 2009, what is the difference between the Savings(current US$) in Croatia and Savings(current US$) in Macao?
Your answer should be compact. -7.71e+09. In the year 2009, what is the difference between the Savings(current US$) of Croatia and Savings(current US$) of Nicaragua?
Keep it short and to the point. 1.57e+09. In the year 2009, what is the difference between the Savings(current US$) of Czech Republic and Savings(current US$) of Macao?
Your response must be concise. -7.38e+09. In the year 2009, what is the difference between the Savings(current US$) in Czech Republic and Savings(current US$) in Nicaragua?
Give a very brief answer. 1.90e+09. In the year 2009, what is the difference between the Savings(current US$) in Macao and Savings(current US$) in Nicaragua?
Your response must be concise. 9.28e+09. In the year 2010, what is the difference between the Savings(current US$) in Croatia and Savings(current US$) in Czech Republic?
Your response must be concise. 1.99e+08. In the year 2010, what is the difference between the Savings(current US$) in Croatia and Savings(current US$) in Macao?
Give a very brief answer. -1.33e+1. In the year 2010, what is the difference between the Savings(current US$) of Croatia and Savings(current US$) of Nicaragua?
Make the answer very short. 1.12e+09. In the year 2010, what is the difference between the Savings(current US$) of Czech Republic and Savings(current US$) of Macao?
Offer a terse response. -1.35e+1. In the year 2010, what is the difference between the Savings(current US$) of Czech Republic and Savings(current US$) of Nicaragua?
Ensure brevity in your answer.  9.16e+08. In the year 2010, what is the difference between the Savings(current US$) in Macao and Savings(current US$) in Nicaragua?
Your response must be concise. 1.44e+1. In the year 2011, what is the difference between the Savings(current US$) in Croatia and Savings(current US$) in Czech Republic?
Ensure brevity in your answer.  -1.00e+09. In the year 2011, what is the difference between the Savings(current US$) in Croatia and Savings(current US$) in Macao?
Provide a short and direct response. -1.80e+1. In the year 2011, what is the difference between the Savings(current US$) of Croatia and Savings(current US$) of Nicaragua?
Keep it short and to the point. 9.61e+08. In the year 2011, what is the difference between the Savings(current US$) of Czech Republic and Savings(current US$) of Macao?
Your answer should be compact. -1.70e+1. In the year 2011, what is the difference between the Savings(current US$) in Czech Republic and Savings(current US$) in Nicaragua?
Give a very brief answer. 1.96e+09. In the year 2011, what is the difference between the Savings(current US$) of Macao and Savings(current US$) of Nicaragua?
Your response must be concise. 1.89e+1. In the year 2012, what is the difference between the Savings(current US$) of Croatia and Savings(current US$) of Czech Republic?
Your answer should be compact. -3.88e+09. In the year 2012, what is the difference between the Savings(current US$) of Croatia and Savings(current US$) of Macao?
Your answer should be very brief. -2.16e+1. In the year 2012, what is the difference between the Savings(current US$) of Croatia and Savings(current US$) of Nicaragua?
Ensure brevity in your answer.  3.61e+08. In the year 2012, what is the difference between the Savings(current US$) of Czech Republic and Savings(current US$) of Macao?
Make the answer very short. -1.78e+1. In the year 2012, what is the difference between the Savings(current US$) in Czech Republic and Savings(current US$) in Nicaragua?
Your answer should be compact. 4.24e+09. In the year 2012, what is the difference between the Savings(current US$) in Macao and Savings(current US$) in Nicaragua?
Provide a short and direct response. 2.20e+1. In the year 2013, what is the difference between the Savings(current US$) in Croatia and Savings(current US$) in Czech Republic?
Provide a short and direct response. -1.24e+09. In the year 2013, what is the difference between the Savings(current US$) of Croatia and Savings(current US$) of Macao?
Your answer should be very brief. -2.51e+1. In the year 2013, what is the difference between the Savings(current US$) of Croatia and Savings(current US$) of Nicaragua?
Keep it short and to the point. 4.00e+08. In the year 2013, what is the difference between the Savings(current US$) of Czech Republic and Savings(current US$) of Macao?
Offer a terse response. -2.38e+1. In the year 2013, what is the difference between the Savings(current US$) of Czech Republic and Savings(current US$) of Nicaragua?
Keep it short and to the point. 1.64e+09. In the year 2013, what is the difference between the Savings(current US$) in Macao and Savings(current US$) in Nicaragua?
Keep it short and to the point. 2.55e+1. What is the ratio of the Savings(current US$) of Croatia in 2006 to that in 2007?
Make the answer very short. 0.91. What is the ratio of the Savings(current US$) of Czech Republic in 2006 to that in 2007?
Ensure brevity in your answer.  0.66. What is the ratio of the Savings(current US$) in Macao in 2006 to that in 2007?
Your response must be concise. 0.67. What is the ratio of the Savings(current US$) of Nicaragua in 2006 to that in 2007?
Your answer should be very brief. 0.77. What is the ratio of the Savings(current US$) in Croatia in 2006 to that in 2008?
Your answer should be compact. 0.74. What is the ratio of the Savings(current US$) in Czech Republic in 2006 to that in 2008?
Your answer should be very brief. 0.65. What is the ratio of the Savings(current US$) in Macao in 2006 to that in 2008?
Your answer should be compact. 0.72. What is the ratio of the Savings(current US$) in Nicaragua in 2006 to that in 2008?
Your answer should be compact. 0.66. What is the ratio of the Savings(current US$) of Croatia in 2006 to that in 2009?
Make the answer very short. 1.64. What is the ratio of the Savings(current US$) of Czech Republic in 2006 to that in 2009?
Provide a short and direct response. 3.24. What is the ratio of the Savings(current US$) in Macao in 2006 to that in 2009?
Keep it short and to the point. 0.7. What is the ratio of the Savings(current US$) in Nicaragua in 2006 to that in 2009?
Offer a very short reply. 0.71. What is the ratio of the Savings(current US$) in Croatia in 2006 to that in 2010?
Make the answer very short. 1.97. What is the ratio of the Savings(current US$) in Czech Republic in 2006 to that in 2010?
Offer a very short reply. 4.82. What is the ratio of the Savings(current US$) in Macao in 2006 to that in 2010?
Give a very brief answer. 0.47. What is the ratio of the Savings(current US$) in Nicaragua in 2006 to that in 2010?
Your response must be concise. 0.69. What is the ratio of the Savings(current US$) in Croatia in 2006 to that in 2011?
Offer a very short reply. 1.76. What is the ratio of the Savings(current US$) in Czech Republic in 2006 to that in 2011?
Offer a very short reply. 2.78. What is the ratio of the Savings(current US$) of Macao in 2006 to that in 2011?
Provide a short and direct response. 0.35. What is the ratio of the Savings(current US$) of Nicaragua in 2006 to that in 2011?
Your answer should be very brief. 0.5. What is the ratio of the Savings(current US$) of Croatia in 2006 to that in 2012?
Ensure brevity in your answer.  2.45. What is the ratio of the Savings(current US$) of Czech Republic in 2006 to that in 2012?
Give a very brief answer. 1.7. What is the ratio of the Savings(current US$) in Macao in 2006 to that in 2012?
Your answer should be compact. 0.31. What is the ratio of the Savings(current US$) of Nicaragua in 2006 to that in 2012?
Provide a succinct answer. 0.53. What is the ratio of the Savings(current US$) of Croatia in 2006 to that in 2013?
Offer a terse response. 2.35. What is the ratio of the Savings(current US$) of Czech Republic in 2006 to that in 2013?
Your answer should be compact. 3.12. What is the ratio of the Savings(current US$) of Macao in 2006 to that in 2013?
Keep it short and to the point. 0.27. What is the ratio of the Savings(current US$) in Nicaragua in 2006 to that in 2013?
Your answer should be very brief. 0.52. What is the ratio of the Savings(current US$) in Croatia in 2007 to that in 2008?
Keep it short and to the point. 0.82. What is the ratio of the Savings(current US$) of Czech Republic in 2007 to that in 2008?
Make the answer very short. 0.99. What is the ratio of the Savings(current US$) in Macao in 2007 to that in 2008?
Keep it short and to the point. 1.08. What is the ratio of the Savings(current US$) in Nicaragua in 2007 to that in 2008?
Keep it short and to the point. 0.86. What is the ratio of the Savings(current US$) of Croatia in 2007 to that in 2009?
Keep it short and to the point. 1.8. What is the ratio of the Savings(current US$) of Czech Republic in 2007 to that in 2009?
Give a very brief answer. 4.91. What is the ratio of the Savings(current US$) in Macao in 2007 to that in 2009?
Offer a terse response. 1.05. What is the ratio of the Savings(current US$) in Nicaragua in 2007 to that in 2009?
Ensure brevity in your answer.  0.92. What is the ratio of the Savings(current US$) in Croatia in 2007 to that in 2010?
Make the answer very short. 2.15. What is the ratio of the Savings(current US$) of Czech Republic in 2007 to that in 2010?
Your response must be concise. 7.3. What is the ratio of the Savings(current US$) in Macao in 2007 to that in 2010?
Keep it short and to the point. 0.7. What is the ratio of the Savings(current US$) in Nicaragua in 2007 to that in 2010?
Ensure brevity in your answer.  0.9. What is the ratio of the Savings(current US$) of Croatia in 2007 to that in 2011?
Offer a terse response. 1.93. What is the ratio of the Savings(current US$) of Czech Republic in 2007 to that in 2011?
Offer a very short reply. 4.21. What is the ratio of the Savings(current US$) of Macao in 2007 to that in 2011?
Your answer should be very brief. 0.53. What is the ratio of the Savings(current US$) in Nicaragua in 2007 to that in 2011?
Your answer should be compact. 0.65. What is the ratio of the Savings(current US$) of Croatia in 2007 to that in 2012?
Keep it short and to the point. 2.68. What is the ratio of the Savings(current US$) in Czech Republic in 2007 to that in 2012?
Offer a terse response. 2.57. What is the ratio of the Savings(current US$) of Macao in 2007 to that in 2012?
Give a very brief answer. 0.46. What is the ratio of the Savings(current US$) of Nicaragua in 2007 to that in 2012?
Ensure brevity in your answer.  0.69. What is the ratio of the Savings(current US$) of Croatia in 2007 to that in 2013?
Your answer should be compact. 2.57. What is the ratio of the Savings(current US$) of Czech Republic in 2007 to that in 2013?
Keep it short and to the point. 4.72. What is the ratio of the Savings(current US$) in Macao in 2007 to that in 2013?
Your answer should be very brief. 0.4. What is the ratio of the Savings(current US$) in Nicaragua in 2007 to that in 2013?
Ensure brevity in your answer.  0.67. What is the ratio of the Savings(current US$) in Croatia in 2008 to that in 2009?
Ensure brevity in your answer.  2.2. What is the ratio of the Savings(current US$) of Czech Republic in 2008 to that in 2009?
Keep it short and to the point. 4.97. What is the ratio of the Savings(current US$) of Macao in 2008 to that in 2009?
Your response must be concise. 0.97. What is the ratio of the Savings(current US$) in Nicaragua in 2008 to that in 2009?
Your answer should be compact. 1.07. What is the ratio of the Savings(current US$) of Croatia in 2008 to that in 2010?
Give a very brief answer. 2.64. What is the ratio of the Savings(current US$) of Czech Republic in 2008 to that in 2010?
Ensure brevity in your answer.  7.38. What is the ratio of the Savings(current US$) of Macao in 2008 to that in 2010?
Offer a terse response. 0.65. What is the ratio of the Savings(current US$) of Nicaragua in 2008 to that in 2010?
Offer a terse response. 1.05. What is the ratio of the Savings(current US$) in Croatia in 2008 to that in 2011?
Offer a terse response. 2.36. What is the ratio of the Savings(current US$) in Czech Republic in 2008 to that in 2011?
Ensure brevity in your answer.  4.26. What is the ratio of the Savings(current US$) in Macao in 2008 to that in 2011?
Make the answer very short. 0.49. What is the ratio of the Savings(current US$) in Nicaragua in 2008 to that in 2011?
Offer a very short reply. 0.76. What is the ratio of the Savings(current US$) in Croatia in 2008 to that in 2012?
Ensure brevity in your answer.  3.29. What is the ratio of the Savings(current US$) of Czech Republic in 2008 to that in 2012?
Your response must be concise. 2.6. What is the ratio of the Savings(current US$) in Macao in 2008 to that in 2012?
Make the answer very short. 0.43. What is the ratio of the Savings(current US$) in Nicaragua in 2008 to that in 2012?
Provide a short and direct response. 0.81. What is the ratio of the Savings(current US$) of Croatia in 2008 to that in 2013?
Offer a very short reply. 3.16. What is the ratio of the Savings(current US$) of Czech Republic in 2008 to that in 2013?
Your response must be concise. 4.77. What is the ratio of the Savings(current US$) of Macao in 2008 to that in 2013?
Your answer should be very brief. 0.37. What is the ratio of the Savings(current US$) in Nicaragua in 2008 to that in 2013?
Your answer should be very brief. 0.79. What is the ratio of the Savings(current US$) in Croatia in 2009 to that in 2010?
Provide a short and direct response. 1.2. What is the ratio of the Savings(current US$) in Czech Republic in 2009 to that in 2010?
Your answer should be very brief. 1.49. What is the ratio of the Savings(current US$) in Macao in 2009 to that in 2010?
Offer a very short reply. 0.67. What is the ratio of the Savings(current US$) of Nicaragua in 2009 to that in 2010?
Provide a succinct answer. 0.98. What is the ratio of the Savings(current US$) in Croatia in 2009 to that in 2011?
Provide a short and direct response. 1.07. What is the ratio of the Savings(current US$) in Czech Republic in 2009 to that in 2011?
Give a very brief answer. 0.86. What is the ratio of the Savings(current US$) in Macao in 2009 to that in 2011?
Keep it short and to the point. 0.51. What is the ratio of the Savings(current US$) of Nicaragua in 2009 to that in 2011?
Keep it short and to the point. 0.71. What is the ratio of the Savings(current US$) of Croatia in 2009 to that in 2012?
Your answer should be compact. 1.49. What is the ratio of the Savings(current US$) of Czech Republic in 2009 to that in 2012?
Ensure brevity in your answer.  0.52. What is the ratio of the Savings(current US$) in Macao in 2009 to that in 2012?
Provide a succinct answer. 0.44. What is the ratio of the Savings(current US$) of Nicaragua in 2009 to that in 2012?
Give a very brief answer. 0.76. What is the ratio of the Savings(current US$) in Croatia in 2009 to that in 2013?
Ensure brevity in your answer.  1.43. What is the ratio of the Savings(current US$) of Czech Republic in 2009 to that in 2013?
Offer a terse response. 0.96. What is the ratio of the Savings(current US$) in Macao in 2009 to that in 2013?
Give a very brief answer. 0.38. What is the ratio of the Savings(current US$) in Nicaragua in 2009 to that in 2013?
Your answer should be compact. 0.74. What is the ratio of the Savings(current US$) of Croatia in 2010 to that in 2011?
Offer a terse response. 0.9. What is the ratio of the Savings(current US$) of Czech Republic in 2010 to that in 2011?
Provide a short and direct response. 0.58. What is the ratio of the Savings(current US$) of Macao in 2010 to that in 2011?
Ensure brevity in your answer.  0.76. What is the ratio of the Savings(current US$) in Nicaragua in 2010 to that in 2011?
Ensure brevity in your answer.  0.72. What is the ratio of the Savings(current US$) in Croatia in 2010 to that in 2012?
Ensure brevity in your answer.  1.25. What is the ratio of the Savings(current US$) in Czech Republic in 2010 to that in 2012?
Make the answer very short. 0.35. What is the ratio of the Savings(current US$) of Macao in 2010 to that in 2012?
Give a very brief answer. 0.66. What is the ratio of the Savings(current US$) of Nicaragua in 2010 to that in 2012?
Provide a short and direct response. 0.77. What is the ratio of the Savings(current US$) of Croatia in 2010 to that in 2013?
Keep it short and to the point. 1.2. What is the ratio of the Savings(current US$) in Czech Republic in 2010 to that in 2013?
Your answer should be very brief. 0.65. What is the ratio of the Savings(current US$) of Macao in 2010 to that in 2013?
Offer a terse response. 0.58. What is the ratio of the Savings(current US$) in Nicaragua in 2010 to that in 2013?
Give a very brief answer. 0.75. What is the ratio of the Savings(current US$) of Croatia in 2011 to that in 2012?
Your answer should be very brief. 1.39. What is the ratio of the Savings(current US$) in Czech Republic in 2011 to that in 2012?
Your response must be concise. 0.61. What is the ratio of the Savings(current US$) of Macao in 2011 to that in 2012?
Provide a short and direct response. 0.87. What is the ratio of the Savings(current US$) in Nicaragua in 2011 to that in 2012?
Offer a very short reply. 1.06. What is the ratio of the Savings(current US$) of Croatia in 2011 to that in 2013?
Ensure brevity in your answer.  1.34. What is the ratio of the Savings(current US$) of Czech Republic in 2011 to that in 2013?
Your answer should be very brief. 1.12. What is the ratio of the Savings(current US$) in Macao in 2011 to that in 2013?
Provide a succinct answer. 0.76. What is the ratio of the Savings(current US$) in Nicaragua in 2011 to that in 2013?
Keep it short and to the point. 1.04. What is the ratio of the Savings(current US$) in Croatia in 2012 to that in 2013?
Make the answer very short. 0.96. What is the ratio of the Savings(current US$) of Czech Republic in 2012 to that in 2013?
Provide a succinct answer. 1.83. What is the ratio of the Savings(current US$) of Macao in 2012 to that in 2013?
Offer a terse response. 0.87. What is the ratio of the Savings(current US$) of Nicaragua in 2012 to that in 2013?
Ensure brevity in your answer.  0.97. What is the difference between the highest and the second highest Savings(current US$) in Croatia?
Offer a terse response. 1.07e+09. What is the difference between the highest and the second highest Savings(current US$) of Czech Republic?
Offer a very short reply. 1.61e+08. What is the difference between the highest and the second highest Savings(current US$) of Macao?
Keep it short and to the point. 3.52e+09. What is the difference between the highest and the second highest Savings(current US$) of Nicaragua?
Give a very brief answer. 5.26e+07. What is the difference between the highest and the lowest Savings(current US$) of Croatia?
Your response must be concise. 4.02e+09. What is the difference between the highest and the lowest Savings(current US$) of Czech Republic?
Your answer should be compact. 1.27e+1. What is the difference between the highest and the lowest Savings(current US$) in Macao?
Keep it short and to the point. 1.97e+1. What is the difference between the highest and the lowest Savings(current US$) of Nicaragua?
Ensure brevity in your answer.  7.40e+08. 